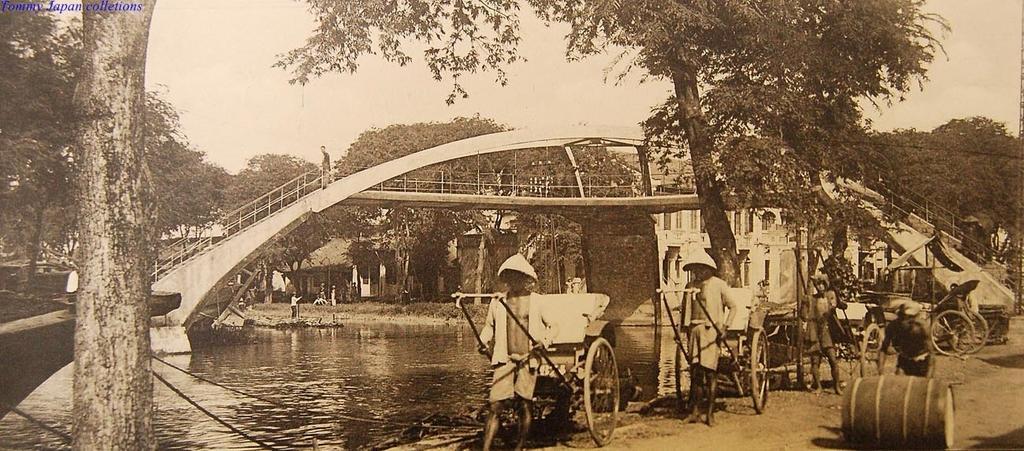In one or two sentences, can you explain what this image depicts? This is a black and white image. In this image, on the right side, we can see a man walking behind the roller. In the middle of the image, we can see a group of people are holding a bicycle. On the left side, we can see wooden trunk, boat, trees. In the background, we can see group of people, bridge, trees, building. At the top, we can see a sky, at the bottom, we can see a water in a lake and a land. 